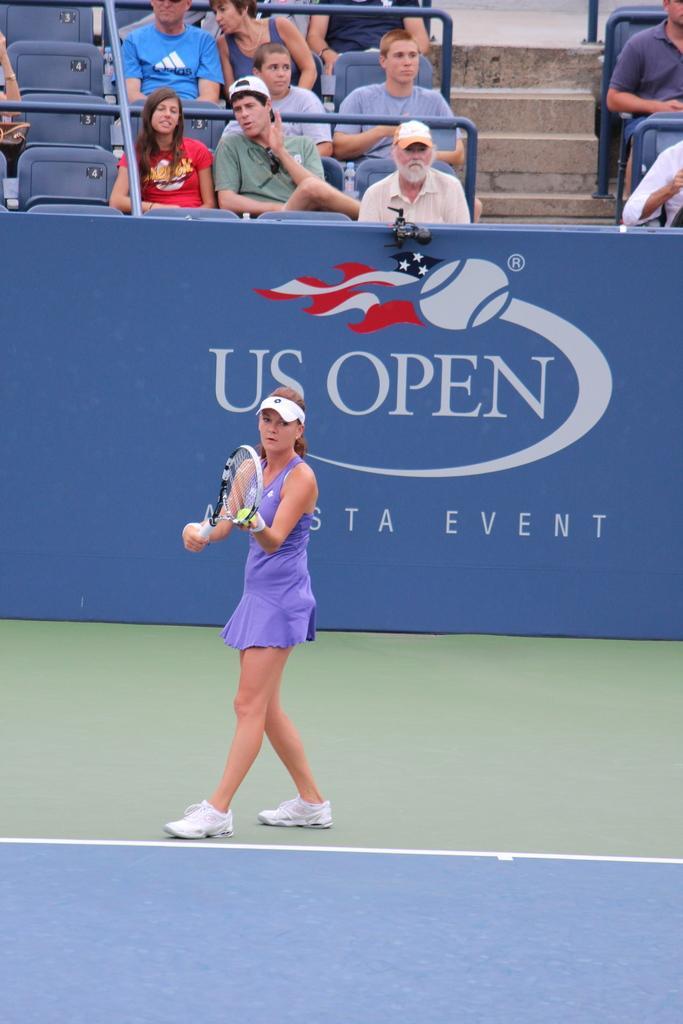Describe this image in one or two sentences. In the picture we can see a woman playing a tennis with the tennis racket, in the background we can find some people sitting and watching her. 